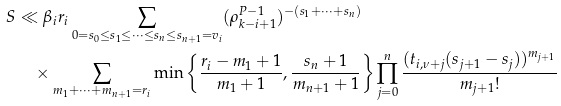<formula> <loc_0><loc_0><loc_500><loc_500>S & \ll \beta _ { i } r _ { i } \sum _ { 0 = s _ { 0 } \leq s _ { 1 } \leq \cdots \leq s _ { n } \leq s _ { n + 1 } = v _ { i } } ( \rho _ { k - i + 1 } ^ { P - 1 } ) ^ { - ( s _ { 1 } + \cdots + s _ { n } ) } \\ & \quad \times \sum _ { m _ { 1 } + \cdots + m _ { n + 1 } = r _ { i } } \min \left \{ \frac { r _ { i } - m _ { 1 } + 1 } { m _ { 1 } + 1 } , \frac { s _ { n } + 1 } { m _ { n + 1 } + 1 } \right \} \prod _ { j = 0 } ^ { n } \frac { ( t _ { i , \nu + j } ( s _ { j + 1 } - s _ { j } ) ) ^ { m _ { j + 1 } } } { m _ { j + 1 } ! }</formula> 